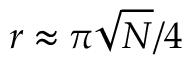Convert formula to latex. <formula><loc_0><loc_0><loc_500><loc_500>r \approx \pi { \sqrt { N } } / 4</formula> 